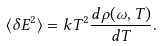Convert formula to latex. <formula><loc_0><loc_0><loc_500><loc_500>\langle \delta E ^ { 2 } \rangle = k T ^ { 2 } \frac { d \rho ( \omega , T ) } { d T } .</formula> 